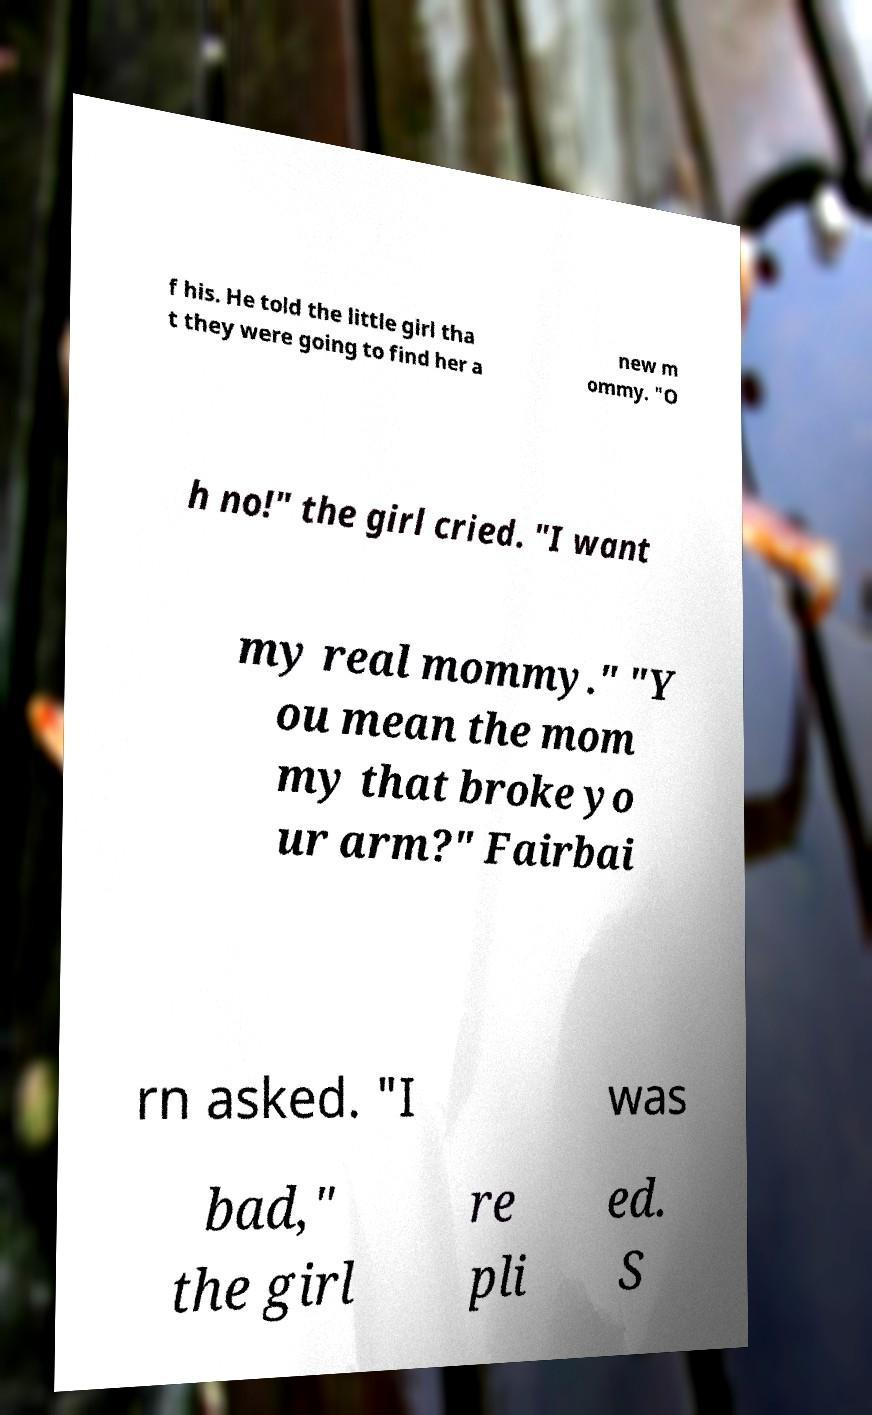Can you read and provide the text displayed in the image?This photo seems to have some interesting text. Can you extract and type it out for me? f his. He told the little girl tha t they were going to find her a new m ommy. "O h no!" the girl cried. "I want my real mommy." "Y ou mean the mom my that broke yo ur arm?" Fairbai rn asked. "I was bad," the girl re pli ed. S 